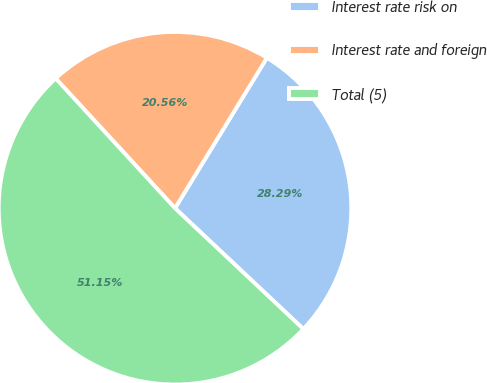<chart> <loc_0><loc_0><loc_500><loc_500><pie_chart><fcel>Interest rate risk on<fcel>Interest rate and foreign<fcel>Total (5)<nl><fcel>28.29%<fcel>20.56%<fcel>51.15%<nl></chart> 